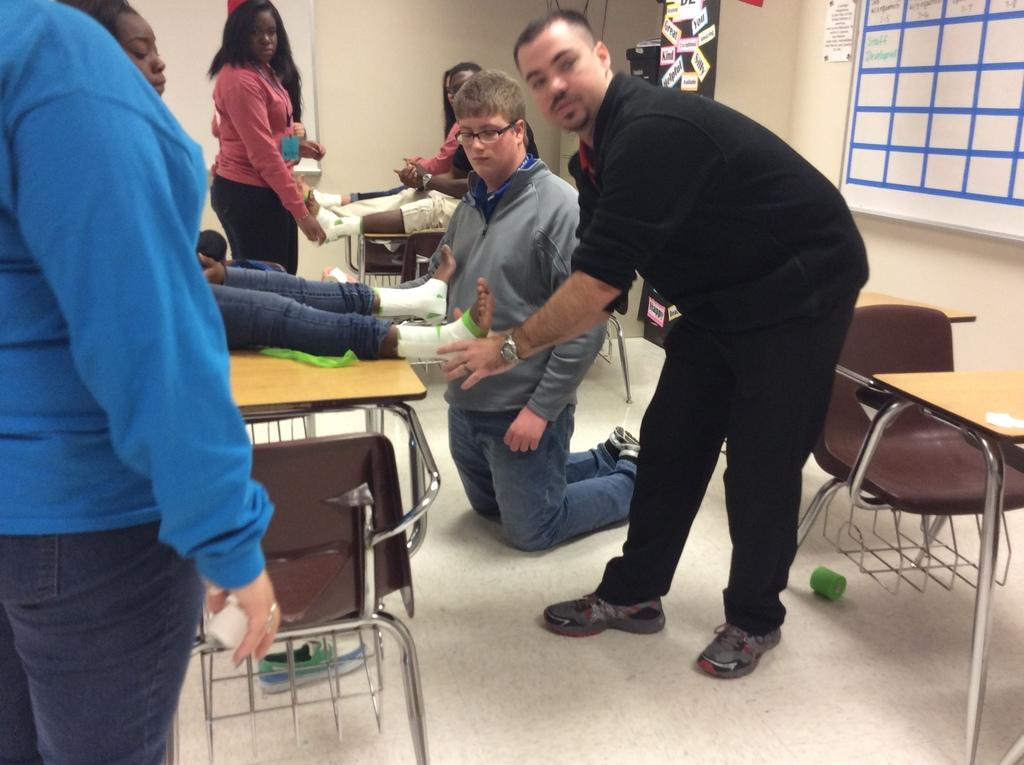What is the main subject of the image? The main subject of the image is a group of people. What are the people in the image doing? The people are standing. What furniture is visible in the image? There are chairs and tables in the image. What type of bell can be heard ringing in the image? There is no bell present or ringing in the image. What type of thread is being used by the people in the image? There is no thread visible or being used by the people in the image. 